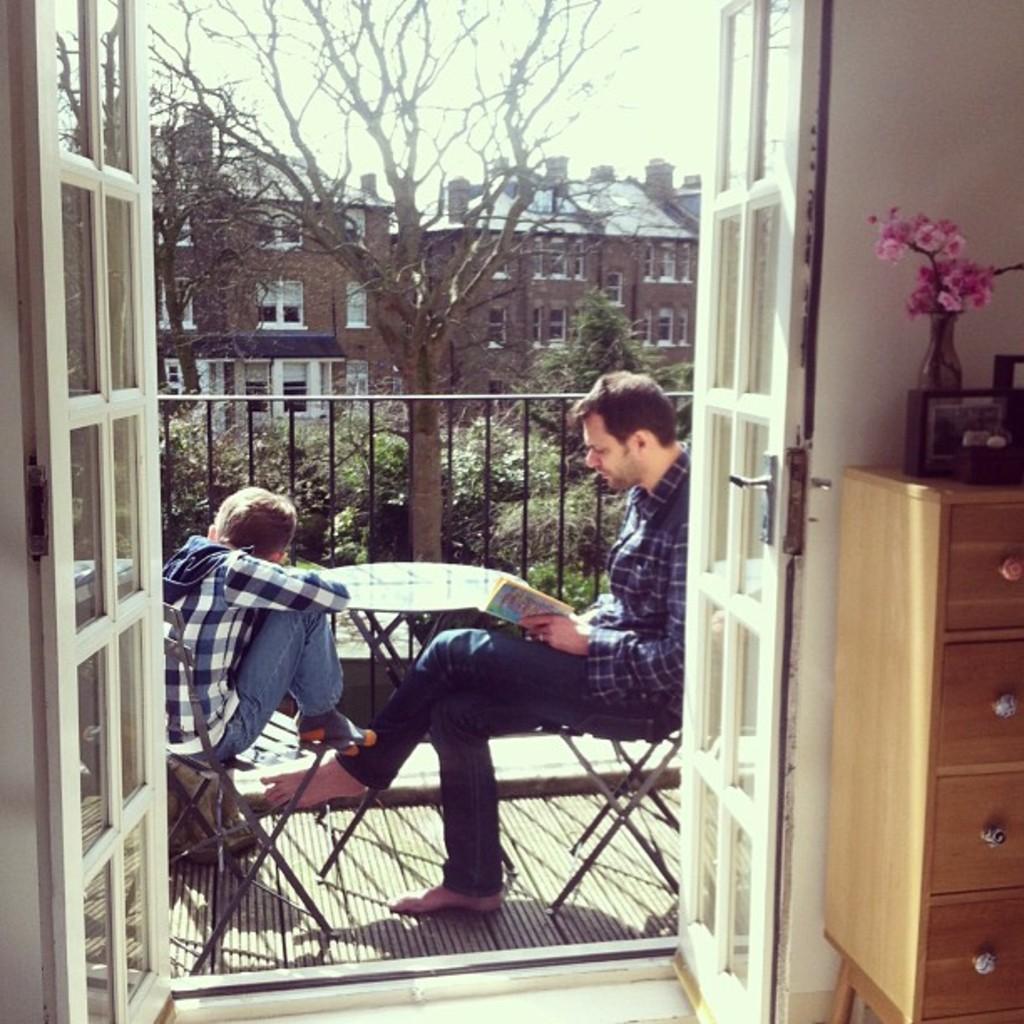Please provide a concise description of this image. In Front portion of the picture we can see a door, near to it there is a desk and we can see a flower vase and a digital clock on the desk. Here we can see a man and a boy sitting on a chair in front of a table. This man is reading a book. This is a balcony. This is a bare tree and on the background of the picture we can see a building. These are plants. At the top of the picture we can see a sky. 